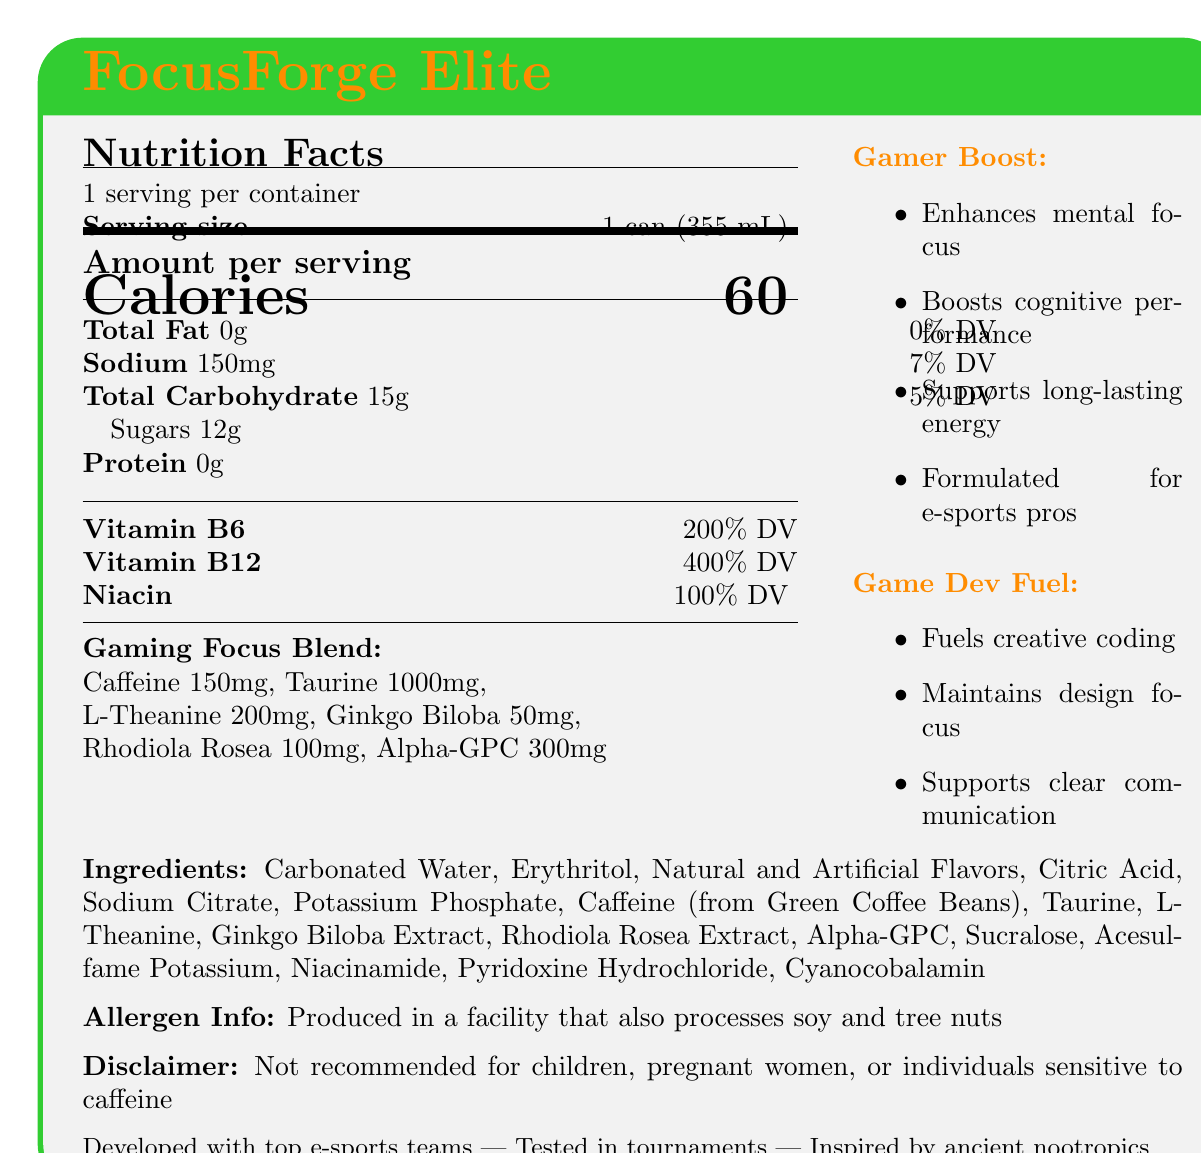What is the serving size of FocusForge Elite? The serving size is specified as "1 can (355 mL)" on the label.
Answer: 1 can (355 mL) How many calories are in one serving of FocusForge Elite? The document states that there are 60 calories per serving.
Answer: 60 calories What percentage of the Daily Value for Vitamin B12 does one serving provide? The label indicates that one serving provides 400% of the Daily Value for Vitamin B12.
Answer: 400% DV List three ingredients found in FocusForge Elite. The ingredients listed in the document include Carbonated Water, Erythritol, and Citric Acid among others.
Answer: Carbonated Water, Erythritol, Citric Acid What is the caffeine content per serving of FocusForge Elite? The label shows that one serving contains 150 mg of caffeine.
Answer: 150 mg Which claim is associated with FocusForge Elite? A. Reduces workout fatigue B. Enhances mental focus C. Improves digestion The document includes a marketing claim stating "Enhances mental focus for intense gaming sessions."
Answer: B. Enhances mental focus What are the forms of flavors used in FocusForge Elite? The ingredient list mentions both Natural and Artificial Flavors.
Answer: Natural and Artificial Flavors What is the sodium content per serving? A. 50 mg B. 100 mg C. 150 mg D. 200 mg The label specifies that there are 150 mg of sodium per serving.
Answer: C. 150 mg Is FocusForge Elite recommended for children? The disclaimer on the document states that it is not recommended for children, pregnant women, or individuals sensitive to caffeine.
Answer: No Summarize the main idea of the document. The document presents FocusForge Elite as a gaming-focused energy drink with specific ingredients and benefits aimed at improving cognitive performance and endurance.
Answer: FocusForge Elite is an energy drink designed for gamers, formulated to enhance mental focus and endurance. It contains vitamins, caffeine, and various nootropics, and is tested by e-sports professionals. What is the main purpose of L-Theanine in FocusForge Elite? The document lists L-Theanine as an ingredient but does not specify its exact purpose.
Answer: Cannot be determined Who collaborated in the development of FocusForge Elite? A. Nutritionists B. Top e-sports teams C. Gym trainers The storytelling elements state that the product was developed in collaboration with top e-sports teams.
Answer: B. Top e-sports teams What is the total carbohydrate content per serving? The label indicates that there are 15 g of total carbohydrates per serving.
Answer: 15 g 